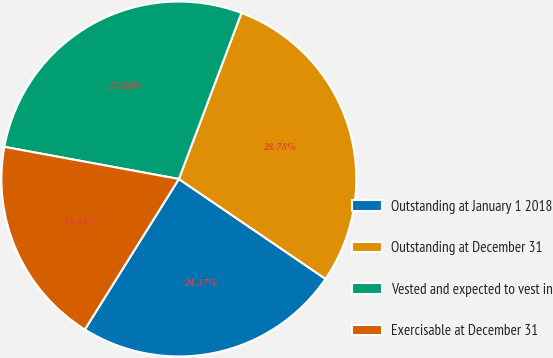<chart> <loc_0><loc_0><loc_500><loc_500><pie_chart><fcel>Outstanding at January 1 2018<fcel>Outstanding at December 31<fcel>Vested and expected to vest in<fcel>Exercisable at December 31<nl><fcel>24.37%<fcel>28.78%<fcel>27.84%<fcel>19.01%<nl></chart> 